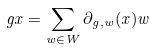Convert formula to latex. <formula><loc_0><loc_0><loc_500><loc_500>g x = \sum _ { w \in W } \partial _ { g , w } ( x ) w</formula> 